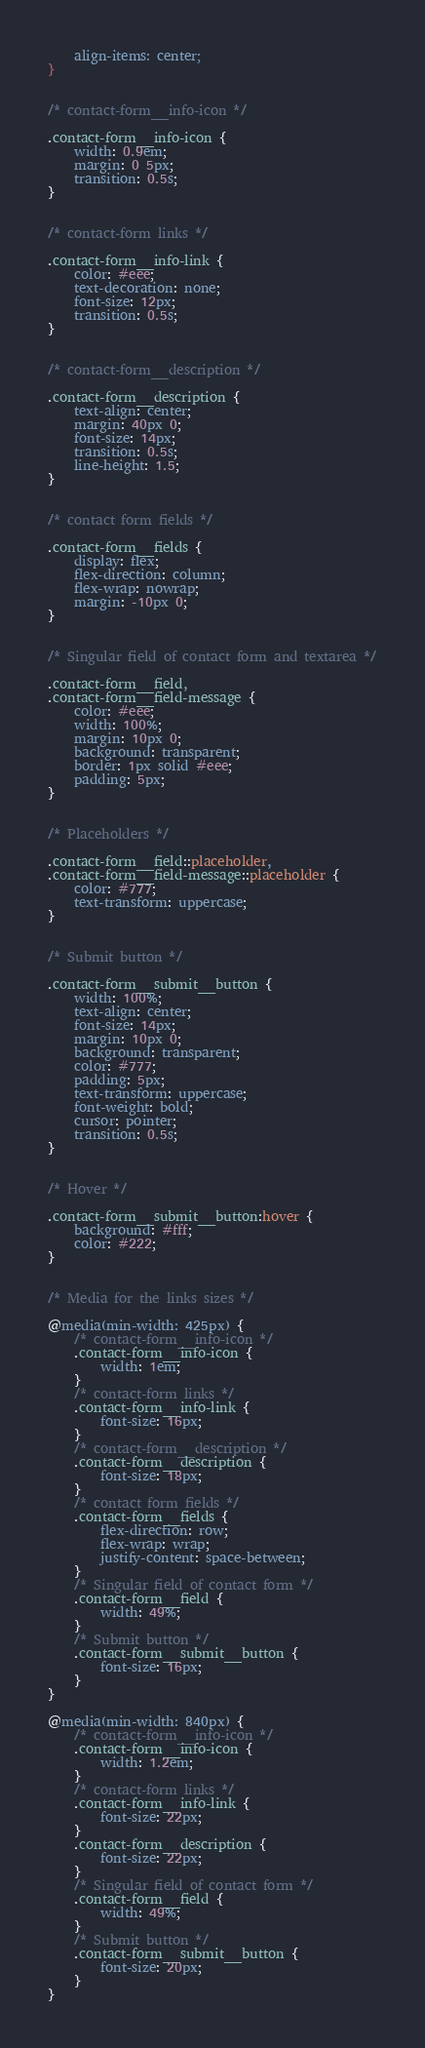Convert code to text. <code><loc_0><loc_0><loc_500><loc_500><_CSS_>    align-items: center;
}


/* contact-form__info-icon */

.contact-form__info-icon {
    width: 0.9em;
    margin: 0 5px;
    transition: 0.5s;
}


/* contact-form links */

.contact-form__info-link {
    color: #eee;
    text-decoration: none;
    font-size: 12px;
    transition: 0.5s;
}


/* contact-form__description */

.contact-form__description {
    text-align: center;
    margin: 40px 0;
    font-size: 14px;
    transition: 0.5s;
    line-height: 1.5;
}


/* contact form fields */

.contact-form__fields {
    display: flex;
    flex-direction: column;
    flex-wrap: nowrap;
    margin: -10px 0;
}


/* Singular field of contact form and textarea */

.contact-form__field,
.contact-form__field-message {
    color: #eee;
    width: 100%;
    margin: 10px 0;
    background: transparent;
    border: 1px solid #eee;
    padding: 5px;
}


/* Placeholders */

.contact-form__field::placeholder,
.contact-form__field-message::placeholder {
    color: #777;
    text-transform: uppercase;
}


/* Submit button */

.contact-form__submit__button {
    width: 100%;
    text-align: center;
    font-size: 14px;
    margin: 10px 0;
    background: transparent;
    color: #777;
    padding: 5px;
    text-transform: uppercase;
    font-weight: bold;
    cursor: pointer;
    transition: 0.5s;
}


/* Hover */

.contact-form__submit__button:hover {
    background: #fff;
    color: #222;
}


/* Media for the links sizes */

@media(min-width: 425px) {
    /* contact-form__info-icon */
    .contact-form__info-icon {
        width: 1em;
    }
    /* contact-form links */
    .contact-form__info-link {
        font-size: 16px;
    }
    /* contact-form__description */
    .contact-form__description {
        font-size: 18px;
    }
    /* contact form fields */
    .contact-form__fields {
        flex-direction: row;
        flex-wrap: wrap;
        justify-content: space-between;
    }
    /* Singular field of contact form */
    .contact-form__field {
        width: 49%;
    }
    /* Submit button */
    .contact-form__submit__button {
        font-size: 16px;
    }
}

@media(min-width: 840px) {
    /* contact-form__info-icon */
    .contact-form__info-icon {
        width: 1.2em;
    }
    /* contact-form links */
    .contact-form__info-link {
        font-size: 22px;
    }
    .contact-form__description {
        font-size: 22px;
    }
    /* Singular field of contact form */
    .contact-form__field {
        width: 49%;
    }
    /* Submit button */
    .contact-form__submit__button {
        font-size: 20px;
    }
}</code> 